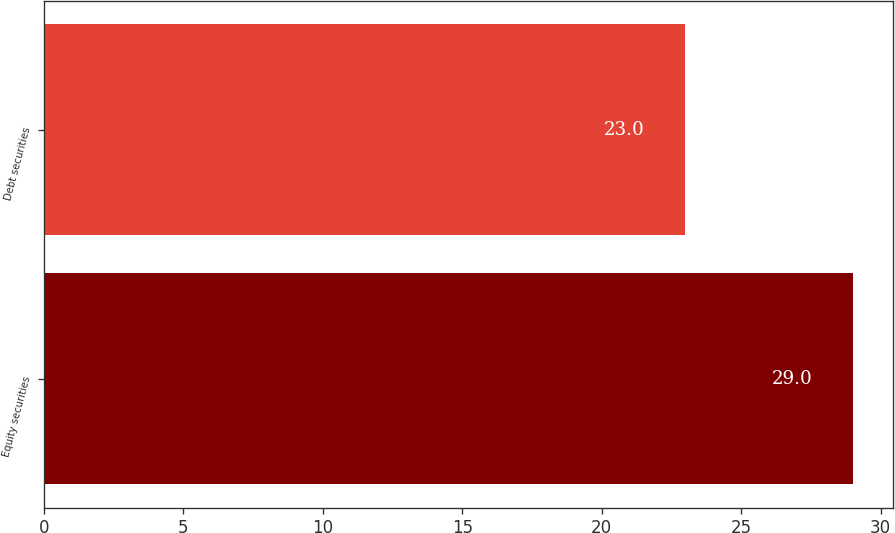Convert chart to OTSL. <chart><loc_0><loc_0><loc_500><loc_500><bar_chart><fcel>Equity securities<fcel>Debt securities<nl><fcel>29<fcel>23<nl></chart> 